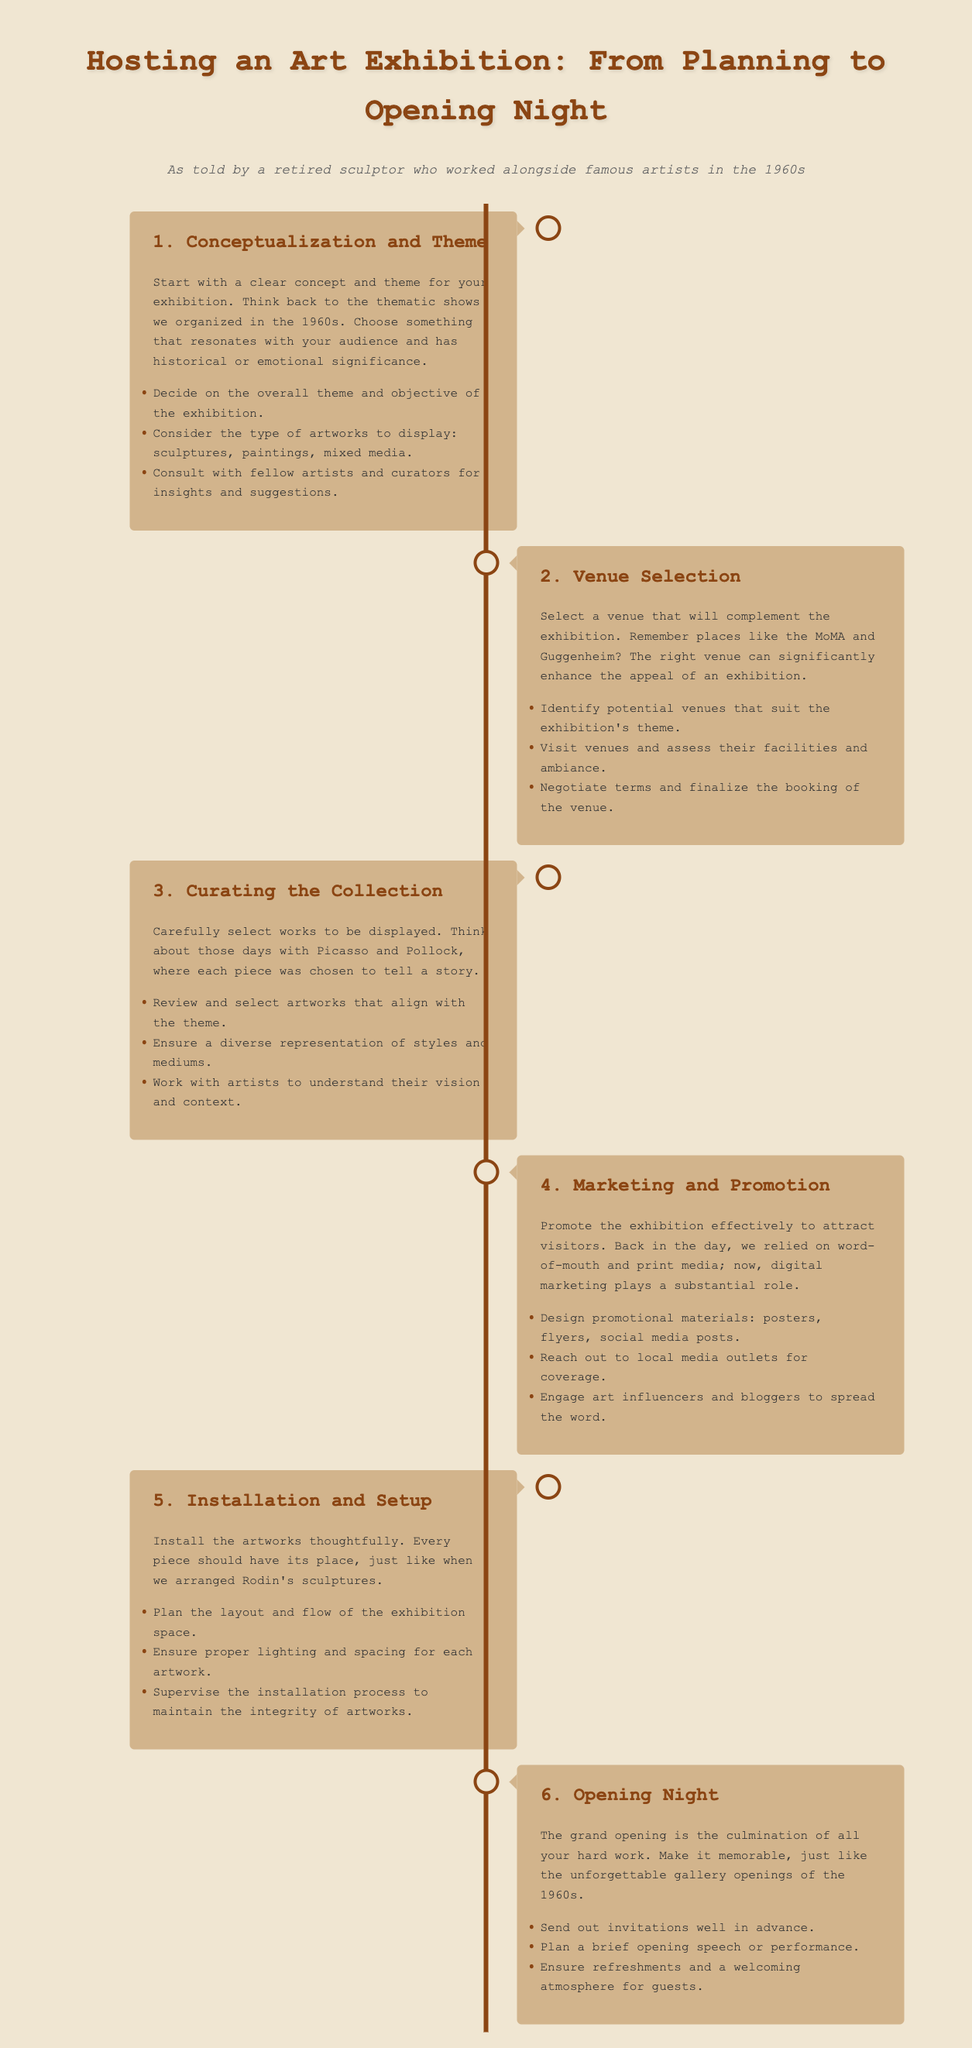What is the first step in hosting an art exhibition? The first step is to start with a clear concept and theme for your exhibition.
Answer: Conceptualization and Theme How many main steps are outlined in the infographic? The infographic outlines six main steps in the process of hosting an art exhibition.
Answer: Six Which type of marketing is emphasized in the document? The document highlights the importance of digital marketing for promoting the exhibition.
Answer: Digital marketing What is crucial for selecting a venue? It is crucial to select a venue that complements the exhibition.
Answer: Complementing the exhibition Who should be consulted for insights during the curating process? Fellow artists and curators should be consulted for insights and suggestions.
Answer: Fellow artists and curators What is the focus of the opening night? The focus of the opening night is to make it memorable.
Answer: Memorable What document structure is used in this infographic? The infographic uses a timeline structure to outline the steps.
Answer: Timeline What should be included in promotional materials? Promotional materials should include posters, flyers, and social media posts.
Answer: Posters, flyers, social media posts 